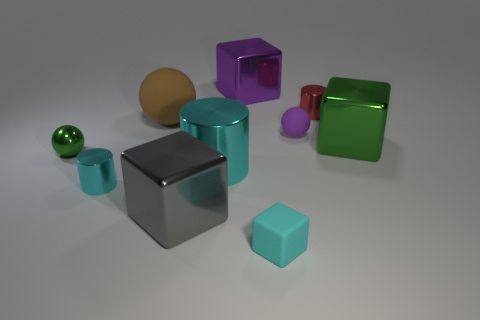Are there any other things that are made of the same material as the large green cube?
Give a very brief answer. Yes. What number of other objects are there of the same material as the green cube?
Provide a short and direct response. 6. Does the gray thing have the same size as the brown sphere?
Keep it short and to the point. Yes. What number of things are either small things in front of the large metal cylinder or gray metal blocks?
Keep it short and to the point. 3. What is the large gray object that is left of the tiny purple sphere that is to the right of the big brown thing made of?
Your response must be concise. Metal. Is there a small purple rubber thing of the same shape as the tiny red metal thing?
Your answer should be compact. No. Do the red cylinder and the green shiny thing that is right of the large gray shiny object have the same size?
Provide a short and direct response. No. What number of things are tiny shiny things behind the small green object or small cyan things to the right of the small cyan shiny thing?
Offer a very short reply. 2. Is the number of large metal cylinders that are behind the large green metallic cube greater than the number of cyan cylinders?
Your response must be concise. No. How many metal objects have the same size as the gray shiny cube?
Your answer should be compact. 3. 